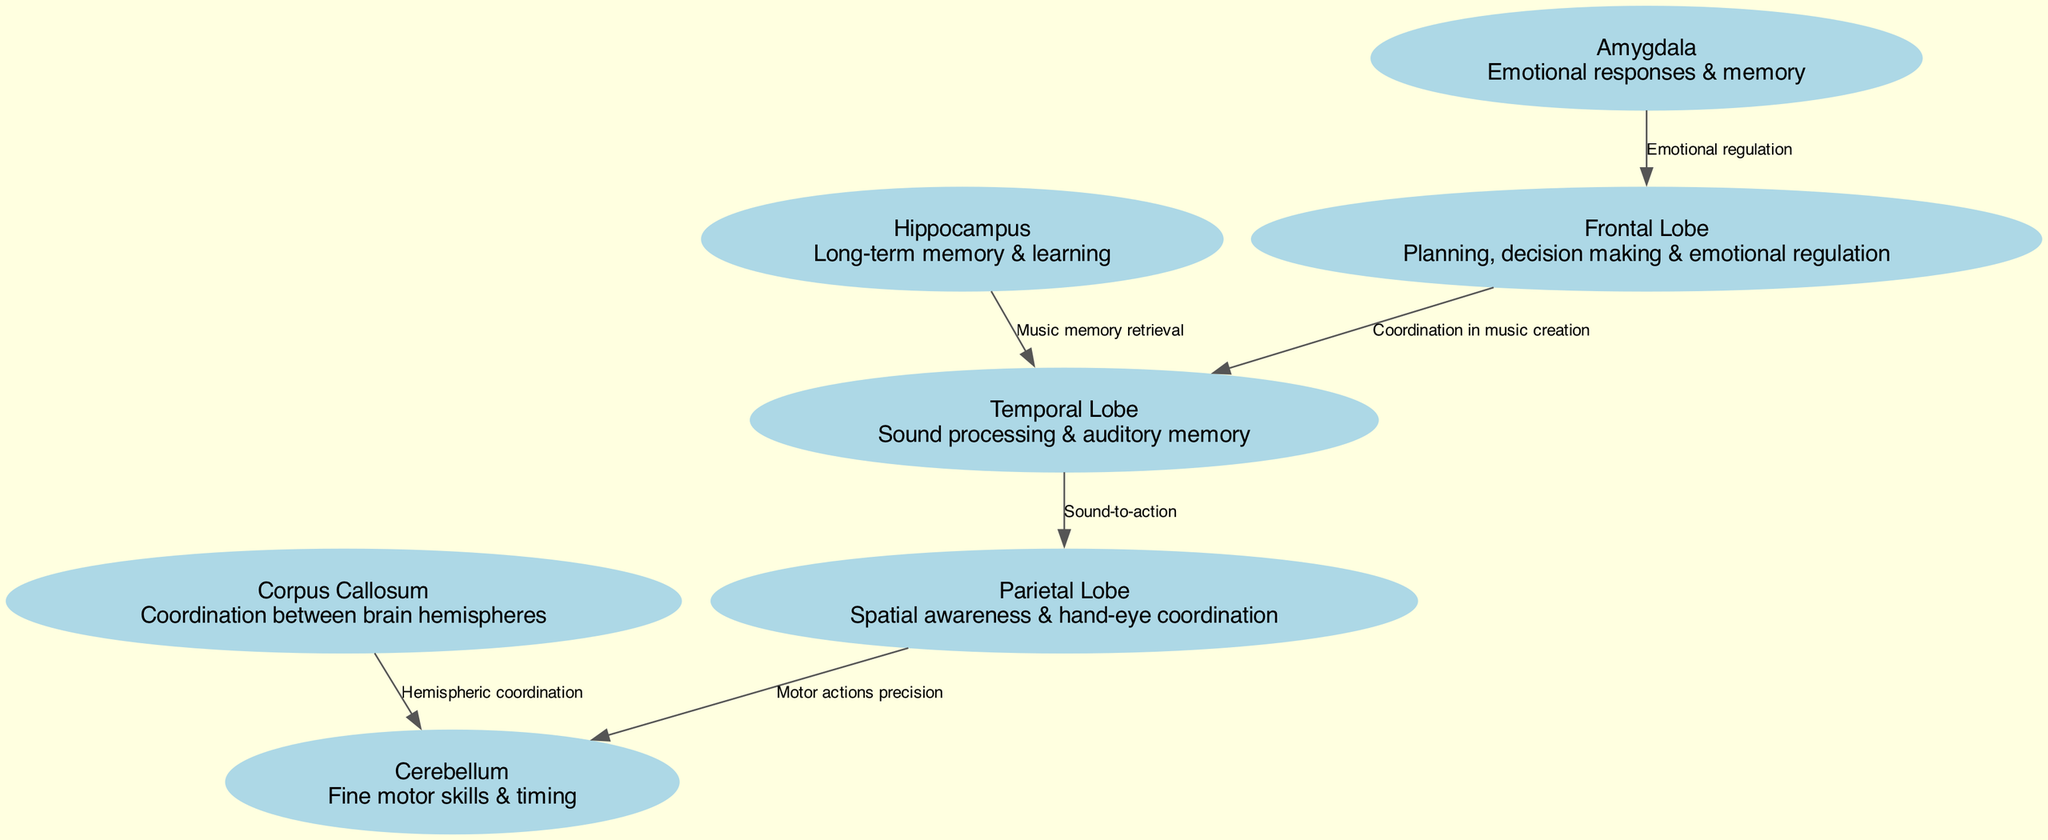What is the total number of nodes in the diagram? The diagram lists six distinct brain regions as nodes: Frontal Lobe, Temporal Lobe, Parietal Lobe, Cerebellum, Hippocampus, and Amygdala. Thus, counting these nodes, the total is six.
Answer: 6 Which node is responsible for emotional regulation? The Frontal Lobe is highlighted for its function in planning, decision making, and emotional regulation. This is specified directly in its description within the diagram.
Answer: Frontal Lobe What connects the Frontal Lobe and the Temporal Lobe? The edge connecting the Frontal Lobe and Temporal Lobe is labeled "Coordination in music creation," which indicates the relationship between these two regions in terms of their collaborative role in music.
Answer: Coordination in music creation How many edges are in the diagram? The diagram shows six edges connecting the nodes: one for each relationship stated, such as "Sound-to-action" and "Music memory retrieval." Counting all these relationships gives a total of six edges.
Answer: 6 What is the primary function of the Hippocampus? The Hippocampus is described as involved in long-term memory and learning, which is explicitly presented in its node description. Therefore, its primary function is in memory and learning processes.
Answer: Long-term memory & learning Which brain region has a relationship with both the Temporal Lobe and Frontal Lobe? The diagram establishes a relationship between the Temporal Lobe and both the Hippocampus and Frontal Lobe. Thus, the Hippocampus is directly linked to the Temporal Lobe and contributes to music memory retrieval, while the Frontal Lobe influences emotional regulation in the music creation process.
Answer: Hippocampus Is there a direct connection between the Parietal Lobe and Cerebellum? Yes, there is a direct connection between the Parietal Lobe and Cerebellum. The edge labeled "Motor actions precision" illustrates this relationship, emphasizing the role this connection plays in the coordination of motor actions in musical performance.
Answer: Yes Which two brain regions are coordinated by the Corpus Callosum? The Corpus Callosum coordinates the Cerebellum and the other hemisphere, serving to facilitate interaction between the left and right sides of the brain during musical performance.
Answer: Cerebellum What is the role of the Amygdala in this diagram? The Amygdala is responsible for handling emotional responses and memory, as indicated by its description: it plays a significant role in how emotional experiences associated with music are processed and remembered.
Answer: Emotional responses & memory 